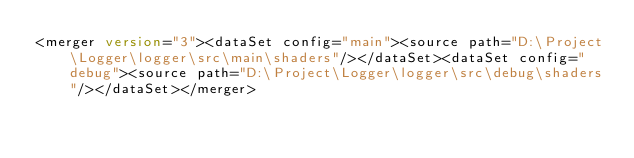<code> <loc_0><loc_0><loc_500><loc_500><_XML_><merger version="3"><dataSet config="main"><source path="D:\Project\Logger\logger\src\main\shaders"/></dataSet><dataSet config="debug"><source path="D:\Project\Logger\logger\src\debug\shaders"/></dataSet></merger></code> 